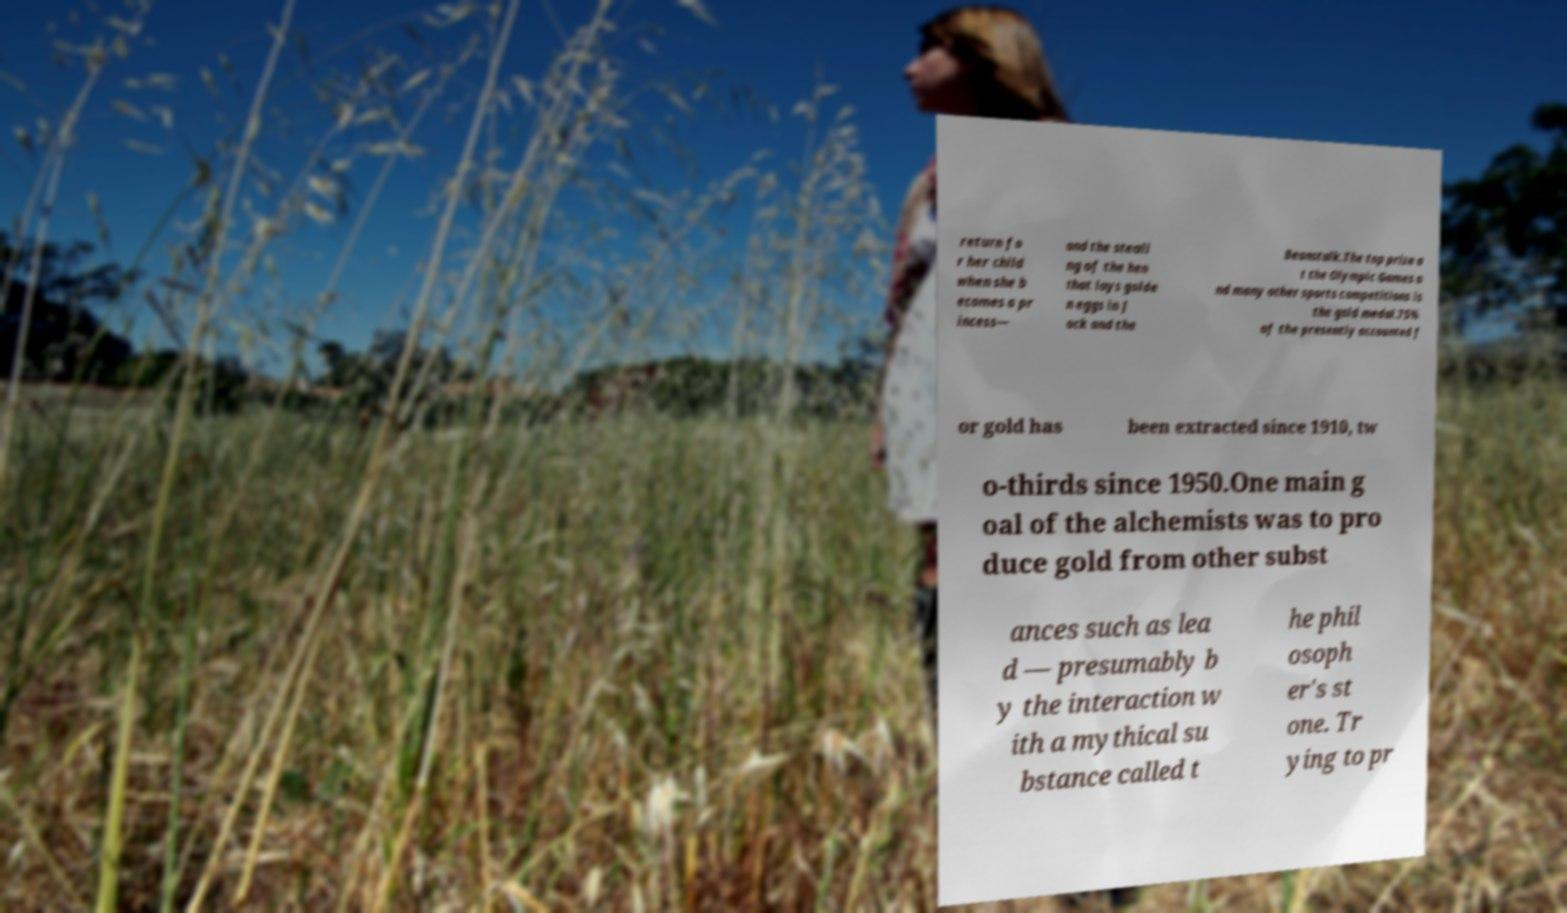Could you assist in decoding the text presented in this image and type it out clearly? return fo r her child when she b ecomes a pr incess— and the steali ng of the hen that lays golde n eggs in J ack and the Beanstalk.The top prize a t the Olympic Games a nd many other sports competitions is the gold medal.75% of the presently accounted f or gold has been extracted since 1910, tw o-thirds since 1950.One main g oal of the alchemists was to pro duce gold from other subst ances such as lea d — presumably b y the interaction w ith a mythical su bstance called t he phil osoph er's st one. Tr ying to pr 